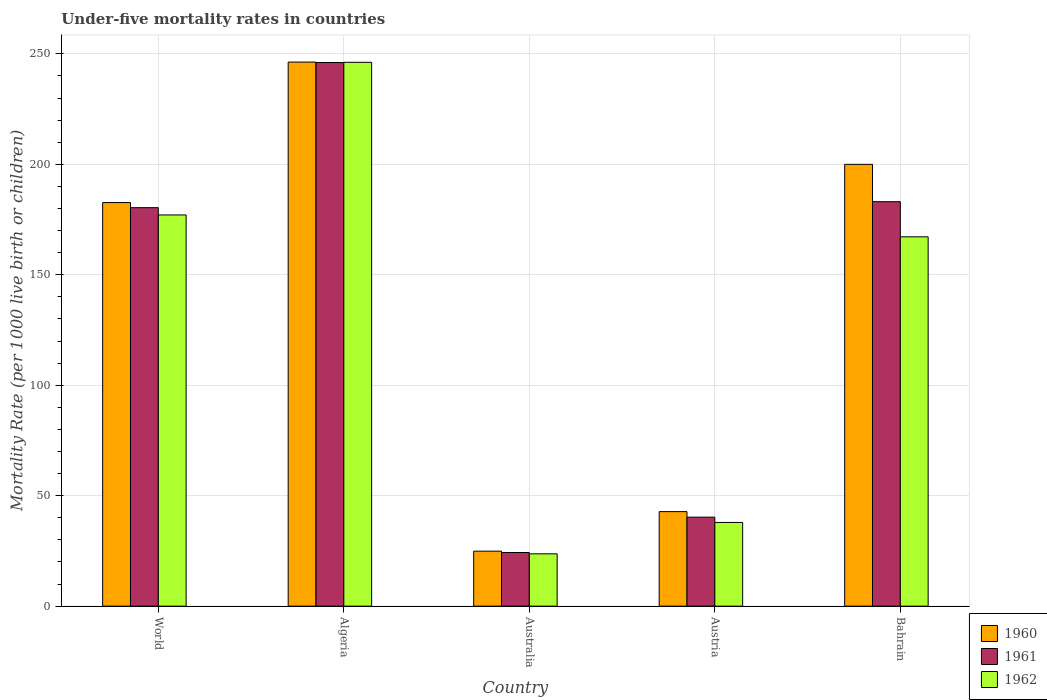How many groups of bars are there?
Your answer should be compact. 5. Are the number of bars on each tick of the X-axis equal?
Offer a terse response. Yes. How many bars are there on the 3rd tick from the left?
Keep it short and to the point. 3. What is the under-five mortality rate in 1961 in Algeria?
Your response must be concise. 246.1. Across all countries, what is the maximum under-five mortality rate in 1961?
Your answer should be very brief. 246.1. Across all countries, what is the minimum under-five mortality rate in 1962?
Ensure brevity in your answer.  23.7. In which country was the under-five mortality rate in 1962 maximum?
Your answer should be compact. Algeria. What is the total under-five mortality rate in 1960 in the graph?
Offer a terse response. 696.7. What is the difference between the under-five mortality rate in 1960 in Algeria and that in Australia?
Your response must be concise. 221.4. What is the difference between the under-five mortality rate in 1962 in Austria and the under-five mortality rate in 1961 in Bahrain?
Offer a very short reply. -145.2. What is the average under-five mortality rate in 1961 per country?
Give a very brief answer. 134.84. What is the difference between the under-five mortality rate of/in 1961 and under-five mortality rate of/in 1960 in Algeria?
Offer a very short reply. -0.2. In how many countries, is the under-five mortality rate in 1961 greater than 170?
Ensure brevity in your answer.  3. What is the ratio of the under-five mortality rate in 1960 in Austria to that in World?
Make the answer very short. 0.23. Is the difference between the under-five mortality rate in 1961 in Australia and World greater than the difference between the under-five mortality rate in 1960 in Australia and World?
Make the answer very short. Yes. What is the difference between the highest and the second highest under-five mortality rate in 1962?
Give a very brief answer. -69.1. What is the difference between the highest and the lowest under-five mortality rate in 1961?
Offer a very short reply. 221.8. Is the sum of the under-five mortality rate in 1961 in Australia and World greater than the maximum under-five mortality rate in 1960 across all countries?
Offer a very short reply. No. What does the 3rd bar from the left in Austria represents?
Ensure brevity in your answer.  1962. What does the 3rd bar from the right in World represents?
Provide a succinct answer. 1960. Is it the case that in every country, the sum of the under-five mortality rate in 1962 and under-five mortality rate in 1960 is greater than the under-five mortality rate in 1961?
Give a very brief answer. Yes. Are all the bars in the graph horizontal?
Provide a short and direct response. No. What is the difference between two consecutive major ticks on the Y-axis?
Your answer should be very brief. 50. Are the values on the major ticks of Y-axis written in scientific E-notation?
Your response must be concise. No. Does the graph contain any zero values?
Your answer should be compact. No. How are the legend labels stacked?
Ensure brevity in your answer.  Vertical. What is the title of the graph?
Provide a short and direct response. Under-five mortality rates in countries. What is the label or title of the Y-axis?
Ensure brevity in your answer.  Mortality Rate (per 1000 live birth or children). What is the Mortality Rate (per 1000 live birth or children) in 1960 in World?
Provide a short and direct response. 182.7. What is the Mortality Rate (per 1000 live birth or children) in 1961 in World?
Offer a very short reply. 180.4. What is the Mortality Rate (per 1000 live birth or children) of 1962 in World?
Make the answer very short. 177.1. What is the Mortality Rate (per 1000 live birth or children) of 1960 in Algeria?
Make the answer very short. 246.3. What is the Mortality Rate (per 1000 live birth or children) in 1961 in Algeria?
Offer a very short reply. 246.1. What is the Mortality Rate (per 1000 live birth or children) in 1962 in Algeria?
Your answer should be very brief. 246.2. What is the Mortality Rate (per 1000 live birth or children) of 1960 in Australia?
Your answer should be very brief. 24.9. What is the Mortality Rate (per 1000 live birth or children) of 1961 in Australia?
Give a very brief answer. 24.3. What is the Mortality Rate (per 1000 live birth or children) of 1962 in Australia?
Give a very brief answer. 23.7. What is the Mortality Rate (per 1000 live birth or children) in 1960 in Austria?
Your response must be concise. 42.8. What is the Mortality Rate (per 1000 live birth or children) of 1961 in Austria?
Offer a terse response. 40.3. What is the Mortality Rate (per 1000 live birth or children) of 1962 in Austria?
Ensure brevity in your answer.  37.9. What is the Mortality Rate (per 1000 live birth or children) in 1960 in Bahrain?
Offer a terse response. 200. What is the Mortality Rate (per 1000 live birth or children) of 1961 in Bahrain?
Ensure brevity in your answer.  183.1. What is the Mortality Rate (per 1000 live birth or children) of 1962 in Bahrain?
Provide a short and direct response. 167.2. Across all countries, what is the maximum Mortality Rate (per 1000 live birth or children) of 1960?
Your answer should be very brief. 246.3. Across all countries, what is the maximum Mortality Rate (per 1000 live birth or children) of 1961?
Provide a succinct answer. 246.1. Across all countries, what is the maximum Mortality Rate (per 1000 live birth or children) of 1962?
Offer a very short reply. 246.2. Across all countries, what is the minimum Mortality Rate (per 1000 live birth or children) in 1960?
Offer a terse response. 24.9. Across all countries, what is the minimum Mortality Rate (per 1000 live birth or children) of 1961?
Keep it short and to the point. 24.3. Across all countries, what is the minimum Mortality Rate (per 1000 live birth or children) in 1962?
Your answer should be very brief. 23.7. What is the total Mortality Rate (per 1000 live birth or children) of 1960 in the graph?
Your answer should be compact. 696.7. What is the total Mortality Rate (per 1000 live birth or children) of 1961 in the graph?
Offer a very short reply. 674.2. What is the total Mortality Rate (per 1000 live birth or children) of 1962 in the graph?
Provide a succinct answer. 652.1. What is the difference between the Mortality Rate (per 1000 live birth or children) in 1960 in World and that in Algeria?
Offer a terse response. -63.6. What is the difference between the Mortality Rate (per 1000 live birth or children) in 1961 in World and that in Algeria?
Your answer should be very brief. -65.7. What is the difference between the Mortality Rate (per 1000 live birth or children) in 1962 in World and that in Algeria?
Make the answer very short. -69.1. What is the difference between the Mortality Rate (per 1000 live birth or children) of 1960 in World and that in Australia?
Ensure brevity in your answer.  157.8. What is the difference between the Mortality Rate (per 1000 live birth or children) of 1961 in World and that in Australia?
Give a very brief answer. 156.1. What is the difference between the Mortality Rate (per 1000 live birth or children) of 1962 in World and that in Australia?
Your answer should be very brief. 153.4. What is the difference between the Mortality Rate (per 1000 live birth or children) in 1960 in World and that in Austria?
Provide a succinct answer. 139.9. What is the difference between the Mortality Rate (per 1000 live birth or children) of 1961 in World and that in Austria?
Your answer should be very brief. 140.1. What is the difference between the Mortality Rate (per 1000 live birth or children) in 1962 in World and that in Austria?
Ensure brevity in your answer.  139.2. What is the difference between the Mortality Rate (per 1000 live birth or children) in 1960 in World and that in Bahrain?
Offer a terse response. -17.3. What is the difference between the Mortality Rate (per 1000 live birth or children) of 1961 in World and that in Bahrain?
Offer a very short reply. -2.7. What is the difference between the Mortality Rate (per 1000 live birth or children) of 1960 in Algeria and that in Australia?
Provide a short and direct response. 221.4. What is the difference between the Mortality Rate (per 1000 live birth or children) in 1961 in Algeria and that in Australia?
Provide a succinct answer. 221.8. What is the difference between the Mortality Rate (per 1000 live birth or children) in 1962 in Algeria and that in Australia?
Offer a terse response. 222.5. What is the difference between the Mortality Rate (per 1000 live birth or children) in 1960 in Algeria and that in Austria?
Offer a terse response. 203.5. What is the difference between the Mortality Rate (per 1000 live birth or children) in 1961 in Algeria and that in Austria?
Ensure brevity in your answer.  205.8. What is the difference between the Mortality Rate (per 1000 live birth or children) in 1962 in Algeria and that in Austria?
Ensure brevity in your answer.  208.3. What is the difference between the Mortality Rate (per 1000 live birth or children) in 1960 in Algeria and that in Bahrain?
Keep it short and to the point. 46.3. What is the difference between the Mortality Rate (per 1000 live birth or children) of 1962 in Algeria and that in Bahrain?
Your answer should be compact. 79. What is the difference between the Mortality Rate (per 1000 live birth or children) of 1960 in Australia and that in Austria?
Ensure brevity in your answer.  -17.9. What is the difference between the Mortality Rate (per 1000 live birth or children) of 1962 in Australia and that in Austria?
Your response must be concise. -14.2. What is the difference between the Mortality Rate (per 1000 live birth or children) in 1960 in Australia and that in Bahrain?
Offer a very short reply. -175.1. What is the difference between the Mortality Rate (per 1000 live birth or children) of 1961 in Australia and that in Bahrain?
Your answer should be compact. -158.8. What is the difference between the Mortality Rate (per 1000 live birth or children) in 1962 in Australia and that in Bahrain?
Offer a very short reply. -143.5. What is the difference between the Mortality Rate (per 1000 live birth or children) in 1960 in Austria and that in Bahrain?
Provide a succinct answer. -157.2. What is the difference between the Mortality Rate (per 1000 live birth or children) of 1961 in Austria and that in Bahrain?
Give a very brief answer. -142.8. What is the difference between the Mortality Rate (per 1000 live birth or children) of 1962 in Austria and that in Bahrain?
Keep it short and to the point. -129.3. What is the difference between the Mortality Rate (per 1000 live birth or children) in 1960 in World and the Mortality Rate (per 1000 live birth or children) in 1961 in Algeria?
Provide a succinct answer. -63.4. What is the difference between the Mortality Rate (per 1000 live birth or children) in 1960 in World and the Mortality Rate (per 1000 live birth or children) in 1962 in Algeria?
Provide a short and direct response. -63.5. What is the difference between the Mortality Rate (per 1000 live birth or children) of 1961 in World and the Mortality Rate (per 1000 live birth or children) of 1962 in Algeria?
Keep it short and to the point. -65.8. What is the difference between the Mortality Rate (per 1000 live birth or children) of 1960 in World and the Mortality Rate (per 1000 live birth or children) of 1961 in Australia?
Ensure brevity in your answer.  158.4. What is the difference between the Mortality Rate (per 1000 live birth or children) in 1960 in World and the Mortality Rate (per 1000 live birth or children) in 1962 in Australia?
Ensure brevity in your answer.  159. What is the difference between the Mortality Rate (per 1000 live birth or children) in 1961 in World and the Mortality Rate (per 1000 live birth or children) in 1962 in Australia?
Keep it short and to the point. 156.7. What is the difference between the Mortality Rate (per 1000 live birth or children) of 1960 in World and the Mortality Rate (per 1000 live birth or children) of 1961 in Austria?
Offer a terse response. 142.4. What is the difference between the Mortality Rate (per 1000 live birth or children) in 1960 in World and the Mortality Rate (per 1000 live birth or children) in 1962 in Austria?
Give a very brief answer. 144.8. What is the difference between the Mortality Rate (per 1000 live birth or children) in 1961 in World and the Mortality Rate (per 1000 live birth or children) in 1962 in Austria?
Your answer should be compact. 142.5. What is the difference between the Mortality Rate (per 1000 live birth or children) in 1960 in Algeria and the Mortality Rate (per 1000 live birth or children) in 1961 in Australia?
Offer a very short reply. 222. What is the difference between the Mortality Rate (per 1000 live birth or children) of 1960 in Algeria and the Mortality Rate (per 1000 live birth or children) of 1962 in Australia?
Provide a short and direct response. 222.6. What is the difference between the Mortality Rate (per 1000 live birth or children) in 1961 in Algeria and the Mortality Rate (per 1000 live birth or children) in 1962 in Australia?
Give a very brief answer. 222.4. What is the difference between the Mortality Rate (per 1000 live birth or children) in 1960 in Algeria and the Mortality Rate (per 1000 live birth or children) in 1961 in Austria?
Offer a very short reply. 206. What is the difference between the Mortality Rate (per 1000 live birth or children) in 1960 in Algeria and the Mortality Rate (per 1000 live birth or children) in 1962 in Austria?
Your response must be concise. 208.4. What is the difference between the Mortality Rate (per 1000 live birth or children) in 1961 in Algeria and the Mortality Rate (per 1000 live birth or children) in 1962 in Austria?
Make the answer very short. 208.2. What is the difference between the Mortality Rate (per 1000 live birth or children) of 1960 in Algeria and the Mortality Rate (per 1000 live birth or children) of 1961 in Bahrain?
Provide a short and direct response. 63.2. What is the difference between the Mortality Rate (per 1000 live birth or children) in 1960 in Algeria and the Mortality Rate (per 1000 live birth or children) in 1962 in Bahrain?
Give a very brief answer. 79.1. What is the difference between the Mortality Rate (per 1000 live birth or children) in 1961 in Algeria and the Mortality Rate (per 1000 live birth or children) in 1962 in Bahrain?
Provide a succinct answer. 78.9. What is the difference between the Mortality Rate (per 1000 live birth or children) of 1960 in Australia and the Mortality Rate (per 1000 live birth or children) of 1961 in Austria?
Offer a terse response. -15.4. What is the difference between the Mortality Rate (per 1000 live birth or children) of 1960 in Australia and the Mortality Rate (per 1000 live birth or children) of 1961 in Bahrain?
Keep it short and to the point. -158.2. What is the difference between the Mortality Rate (per 1000 live birth or children) in 1960 in Australia and the Mortality Rate (per 1000 live birth or children) in 1962 in Bahrain?
Your response must be concise. -142.3. What is the difference between the Mortality Rate (per 1000 live birth or children) of 1961 in Australia and the Mortality Rate (per 1000 live birth or children) of 1962 in Bahrain?
Your response must be concise. -142.9. What is the difference between the Mortality Rate (per 1000 live birth or children) of 1960 in Austria and the Mortality Rate (per 1000 live birth or children) of 1961 in Bahrain?
Make the answer very short. -140.3. What is the difference between the Mortality Rate (per 1000 live birth or children) in 1960 in Austria and the Mortality Rate (per 1000 live birth or children) in 1962 in Bahrain?
Your answer should be very brief. -124.4. What is the difference between the Mortality Rate (per 1000 live birth or children) in 1961 in Austria and the Mortality Rate (per 1000 live birth or children) in 1962 in Bahrain?
Make the answer very short. -126.9. What is the average Mortality Rate (per 1000 live birth or children) in 1960 per country?
Offer a very short reply. 139.34. What is the average Mortality Rate (per 1000 live birth or children) of 1961 per country?
Make the answer very short. 134.84. What is the average Mortality Rate (per 1000 live birth or children) of 1962 per country?
Your answer should be very brief. 130.42. What is the difference between the Mortality Rate (per 1000 live birth or children) in 1960 and Mortality Rate (per 1000 live birth or children) in 1961 in World?
Provide a succinct answer. 2.3. What is the difference between the Mortality Rate (per 1000 live birth or children) in 1961 and Mortality Rate (per 1000 live birth or children) in 1962 in World?
Your response must be concise. 3.3. What is the difference between the Mortality Rate (per 1000 live birth or children) in 1961 and Mortality Rate (per 1000 live birth or children) in 1962 in Algeria?
Make the answer very short. -0.1. What is the difference between the Mortality Rate (per 1000 live birth or children) of 1961 and Mortality Rate (per 1000 live birth or children) of 1962 in Australia?
Provide a short and direct response. 0.6. What is the difference between the Mortality Rate (per 1000 live birth or children) of 1960 and Mortality Rate (per 1000 live birth or children) of 1961 in Austria?
Provide a succinct answer. 2.5. What is the difference between the Mortality Rate (per 1000 live birth or children) of 1961 and Mortality Rate (per 1000 live birth or children) of 1962 in Austria?
Your response must be concise. 2.4. What is the difference between the Mortality Rate (per 1000 live birth or children) of 1960 and Mortality Rate (per 1000 live birth or children) of 1962 in Bahrain?
Your answer should be compact. 32.8. What is the difference between the Mortality Rate (per 1000 live birth or children) of 1961 and Mortality Rate (per 1000 live birth or children) of 1962 in Bahrain?
Provide a succinct answer. 15.9. What is the ratio of the Mortality Rate (per 1000 live birth or children) in 1960 in World to that in Algeria?
Your response must be concise. 0.74. What is the ratio of the Mortality Rate (per 1000 live birth or children) of 1961 in World to that in Algeria?
Make the answer very short. 0.73. What is the ratio of the Mortality Rate (per 1000 live birth or children) of 1962 in World to that in Algeria?
Offer a terse response. 0.72. What is the ratio of the Mortality Rate (per 1000 live birth or children) in 1960 in World to that in Australia?
Offer a terse response. 7.34. What is the ratio of the Mortality Rate (per 1000 live birth or children) of 1961 in World to that in Australia?
Make the answer very short. 7.42. What is the ratio of the Mortality Rate (per 1000 live birth or children) in 1962 in World to that in Australia?
Provide a short and direct response. 7.47. What is the ratio of the Mortality Rate (per 1000 live birth or children) of 1960 in World to that in Austria?
Your answer should be very brief. 4.27. What is the ratio of the Mortality Rate (per 1000 live birth or children) in 1961 in World to that in Austria?
Give a very brief answer. 4.48. What is the ratio of the Mortality Rate (per 1000 live birth or children) of 1962 in World to that in Austria?
Your answer should be very brief. 4.67. What is the ratio of the Mortality Rate (per 1000 live birth or children) of 1960 in World to that in Bahrain?
Provide a short and direct response. 0.91. What is the ratio of the Mortality Rate (per 1000 live birth or children) in 1961 in World to that in Bahrain?
Your answer should be very brief. 0.99. What is the ratio of the Mortality Rate (per 1000 live birth or children) in 1962 in World to that in Bahrain?
Give a very brief answer. 1.06. What is the ratio of the Mortality Rate (per 1000 live birth or children) in 1960 in Algeria to that in Australia?
Ensure brevity in your answer.  9.89. What is the ratio of the Mortality Rate (per 1000 live birth or children) in 1961 in Algeria to that in Australia?
Give a very brief answer. 10.13. What is the ratio of the Mortality Rate (per 1000 live birth or children) in 1962 in Algeria to that in Australia?
Offer a terse response. 10.39. What is the ratio of the Mortality Rate (per 1000 live birth or children) in 1960 in Algeria to that in Austria?
Offer a very short reply. 5.75. What is the ratio of the Mortality Rate (per 1000 live birth or children) of 1961 in Algeria to that in Austria?
Offer a terse response. 6.11. What is the ratio of the Mortality Rate (per 1000 live birth or children) of 1962 in Algeria to that in Austria?
Make the answer very short. 6.5. What is the ratio of the Mortality Rate (per 1000 live birth or children) of 1960 in Algeria to that in Bahrain?
Your answer should be compact. 1.23. What is the ratio of the Mortality Rate (per 1000 live birth or children) in 1961 in Algeria to that in Bahrain?
Your answer should be compact. 1.34. What is the ratio of the Mortality Rate (per 1000 live birth or children) of 1962 in Algeria to that in Bahrain?
Provide a short and direct response. 1.47. What is the ratio of the Mortality Rate (per 1000 live birth or children) of 1960 in Australia to that in Austria?
Ensure brevity in your answer.  0.58. What is the ratio of the Mortality Rate (per 1000 live birth or children) of 1961 in Australia to that in Austria?
Your answer should be compact. 0.6. What is the ratio of the Mortality Rate (per 1000 live birth or children) of 1962 in Australia to that in Austria?
Offer a terse response. 0.63. What is the ratio of the Mortality Rate (per 1000 live birth or children) in 1960 in Australia to that in Bahrain?
Provide a succinct answer. 0.12. What is the ratio of the Mortality Rate (per 1000 live birth or children) of 1961 in Australia to that in Bahrain?
Your response must be concise. 0.13. What is the ratio of the Mortality Rate (per 1000 live birth or children) in 1962 in Australia to that in Bahrain?
Provide a short and direct response. 0.14. What is the ratio of the Mortality Rate (per 1000 live birth or children) in 1960 in Austria to that in Bahrain?
Your answer should be very brief. 0.21. What is the ratio of the Mortality Rate (per 1000 live birth or children) of 1961 in Austria to that in Bahrain?
Offer a terse response. 0.22. What is the ratio of the Mortality Rate (per 1000 live birth or children) in 1962 in Austria to that in Bahrain?
Offer a very short reply. 0.23. What is the difference between the highest and the second highest Mortality Rate (per 1000 live birth or children) of 1960?
Offer a terse response. 46.3. What is the difference between the highest and the second highest Mortality Rate (per 1000 live birth or children) in 1962?
Keep it short and to the point. 69.1. What is the difference between the highest and the lowest Mortality Rate (per 1000 live birth or children) of 1960?
Provide a short and direct response. 221.4. What is the difference between the highest and the lowest Mortality Rate (per 1000 live birth or children) in 1961?
Your answer should be very brief. 221.8. What is the difference between the highest and the lowest Mortality Rate (per 1000 live birth or children) in 1962?
Keep it short and to the point. 222.5. 